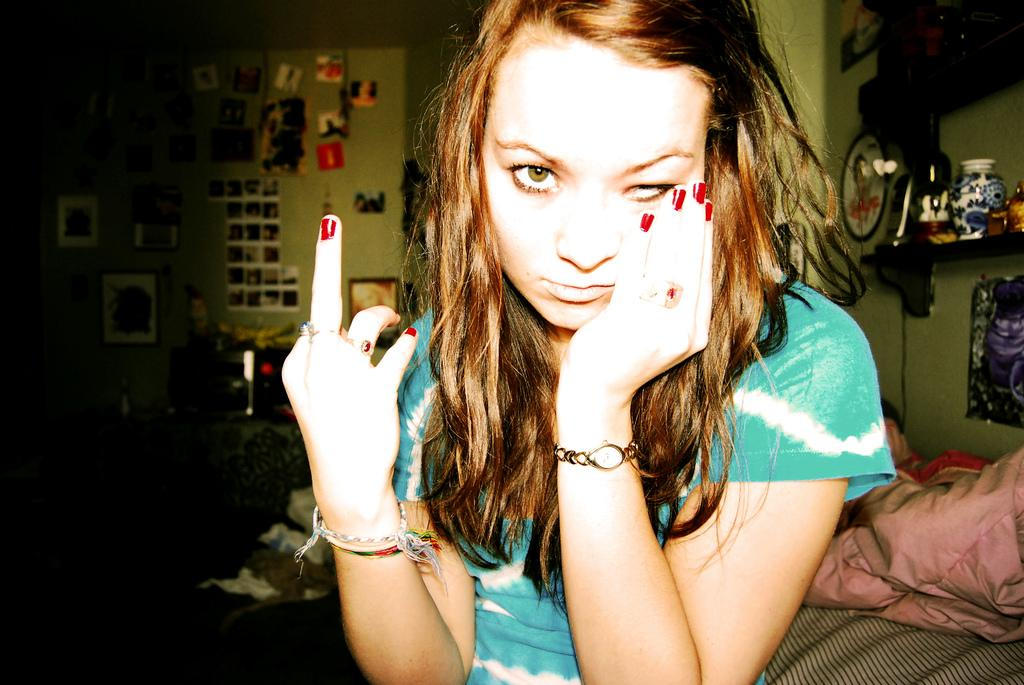Who is present in the image? There is a woman in the image. What items can be seen in the image? There are clothes, a bottle, and a jar visible in the image. What can be seen in the background of the image? There is a wall, frames, and posters in the background of the image. What type of note is being used by the woman in the image? There is no note present in the image; it only features a woman, clothes, a bottle, a jar, a wall, frames, and posters. 